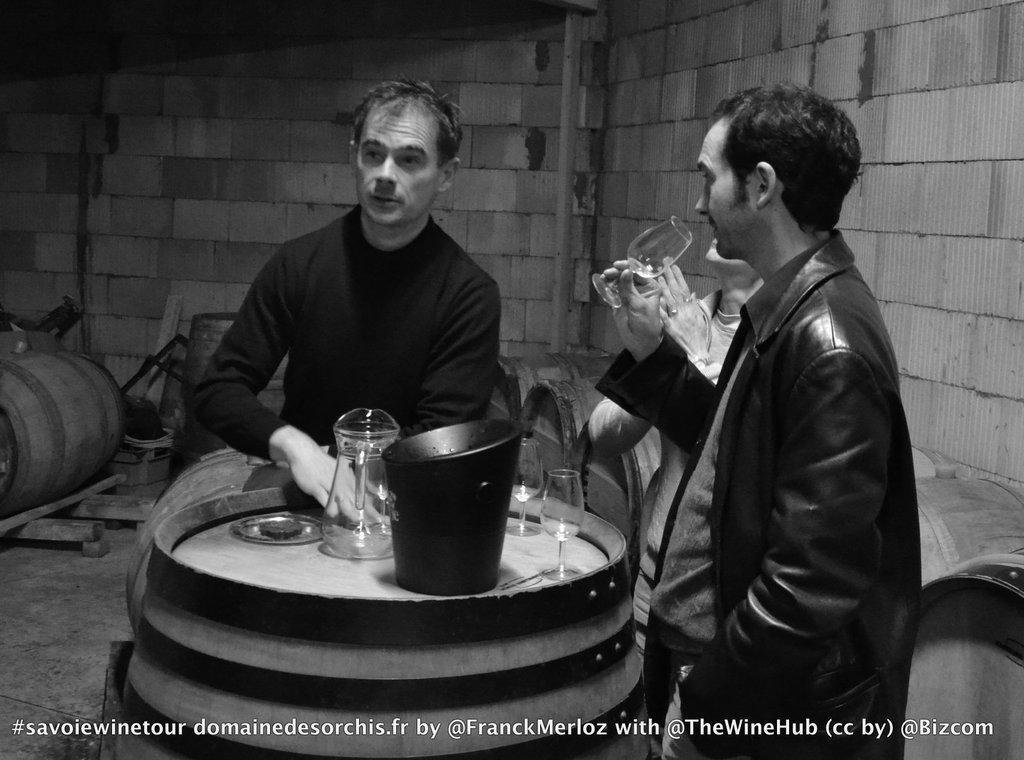Describe this image in one or two sentences. Here we can see a black and white photograph, in this we can see three people, in front of them we can find glasses, a jug, bucket and other things, on the right side of the image we can see a man, he is holding a glass, beside them we can find few barrels, at the bottom of the image we can find some text. 